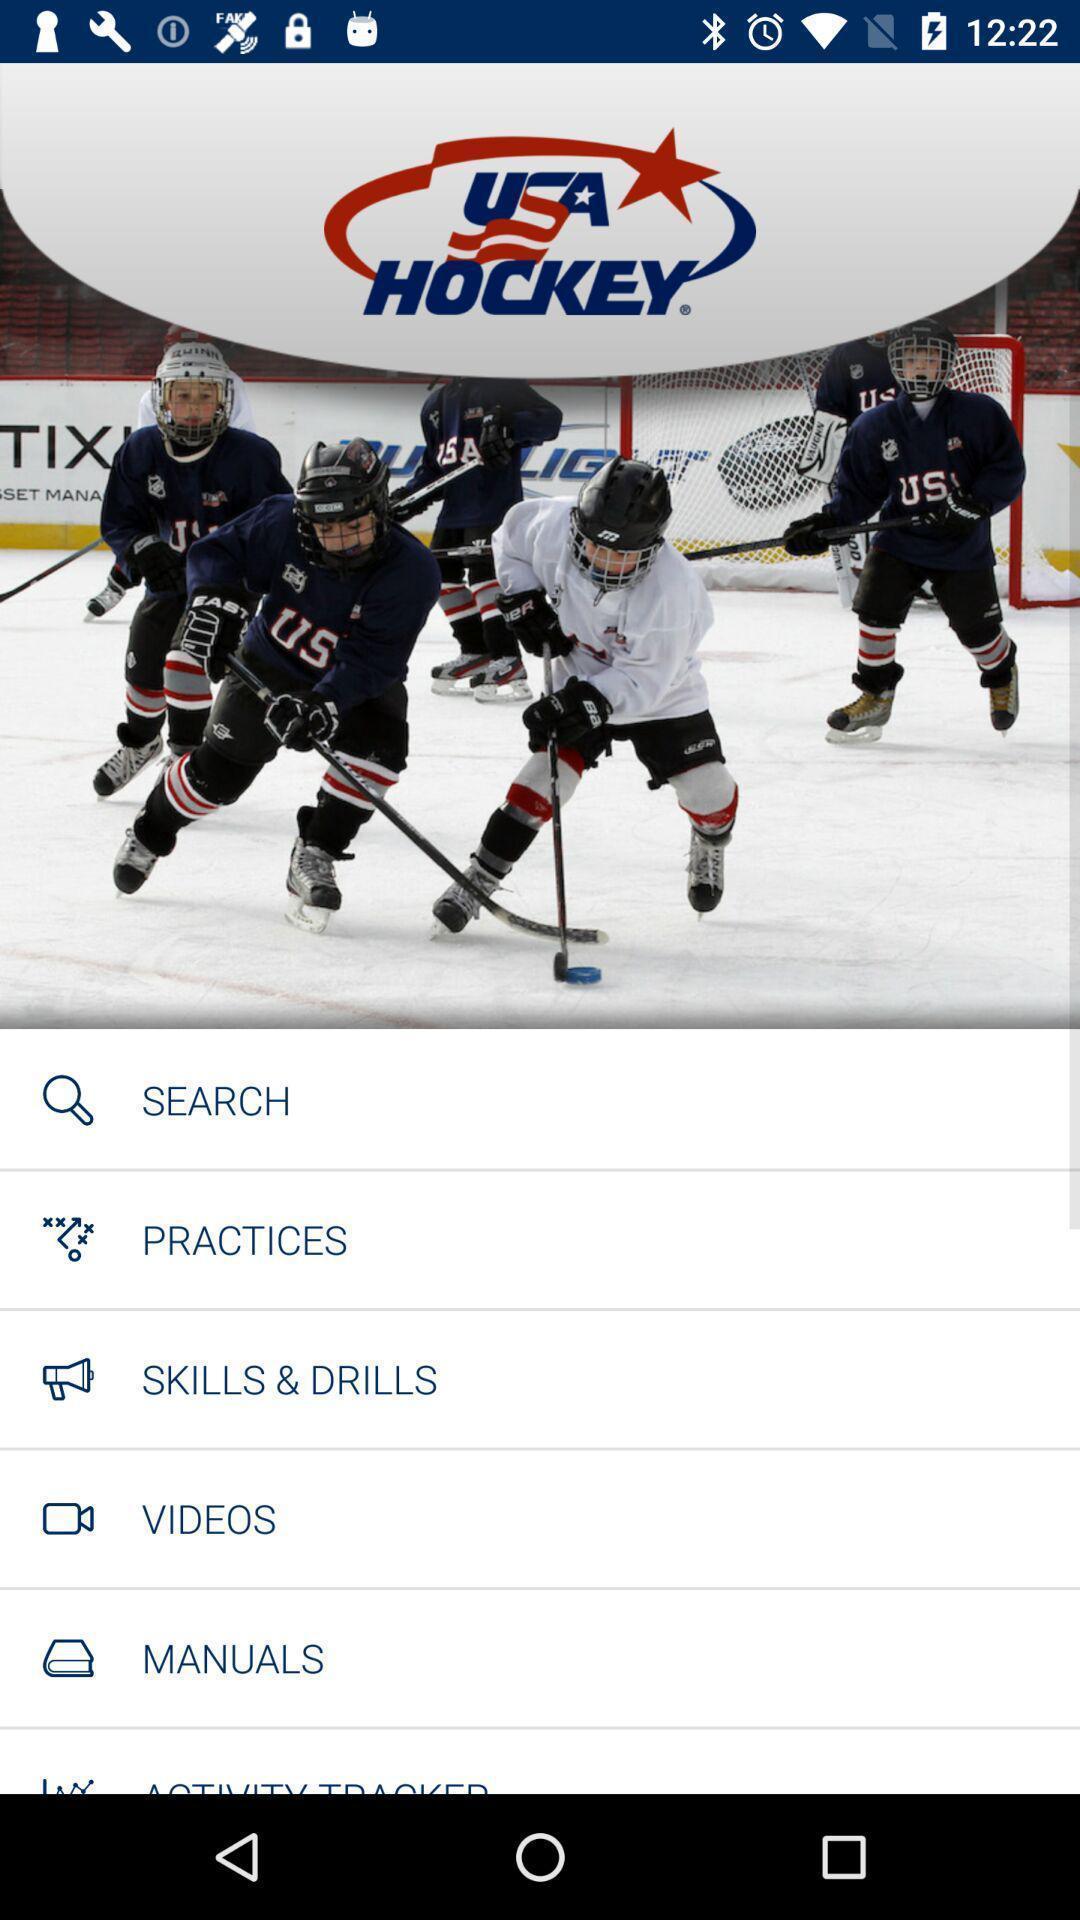Describe the key features of this screenshot. Pop up page displayed includes various options of sports app. 